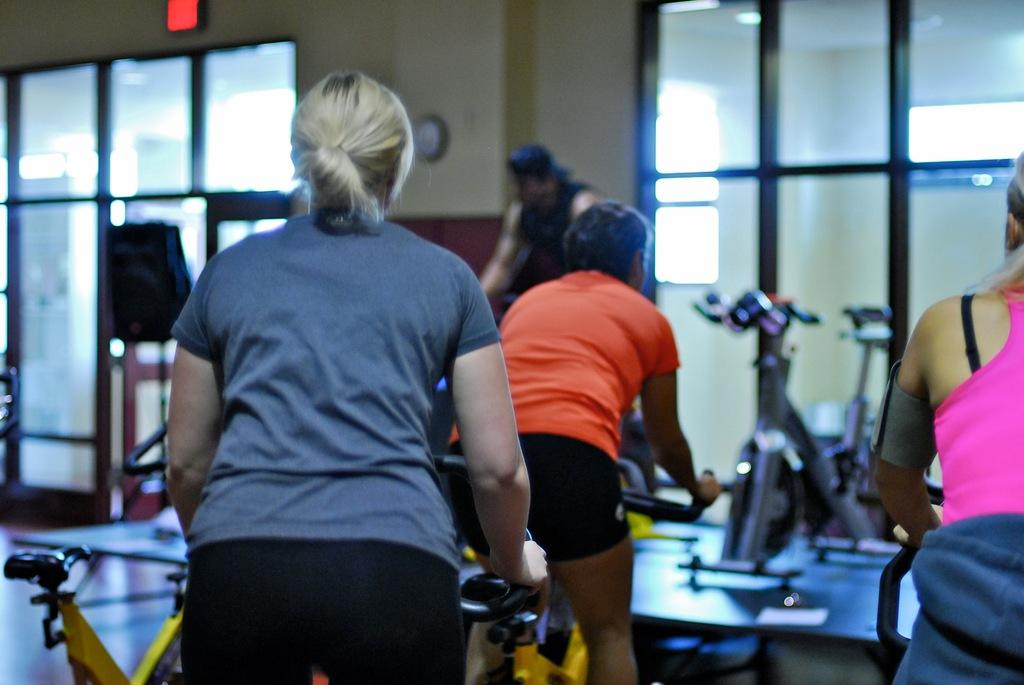What are the people in the image doing? The people in the image are riding cycles. Where are the people located in the image? The people are in the center of the image. What can be seen in the background of the image? There is a wall, glass, and other objects in the background of the image. What type of powder is being used by the people riding cycles in the image? There is no powder visible or mentioned in the image; the people are simply riding cycles. 